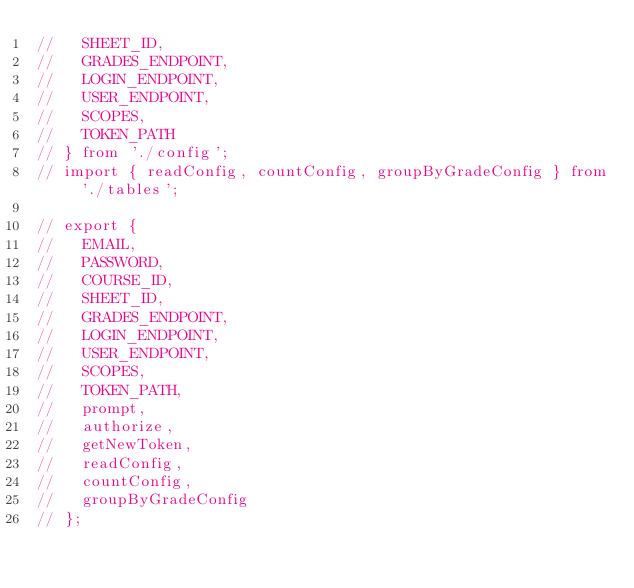<code> <loc_0><loc_0><loc_500><loc_500><_JavaScript_>//   SHEET_ID,
//   GRADES_ENDPOINT,
//   LOGIN_ENDPOINT,
//   USER_ENDPOINT,
//   SCOPES,
//   TOKEN_PATH
// } from './config';
// import { readConfig, countConfig, groupByGradeConfig } from './tables';

// export {
//   EMAIL,
//   PASSWORD,
//   COURSE_ID,
//   SHEET_ID,
//   GRADES_ENDPOINT,
//   LOGIN_ENDPOINT,
//   USER_ENDPOINT,
//   SCOPES,
//   TOKEN_PATH,
//   prompt,
//   authorize,
//   getNewToken,
//   readConfig,
//   countConfig,
//   groupByGradeConfig
// };
</code> 